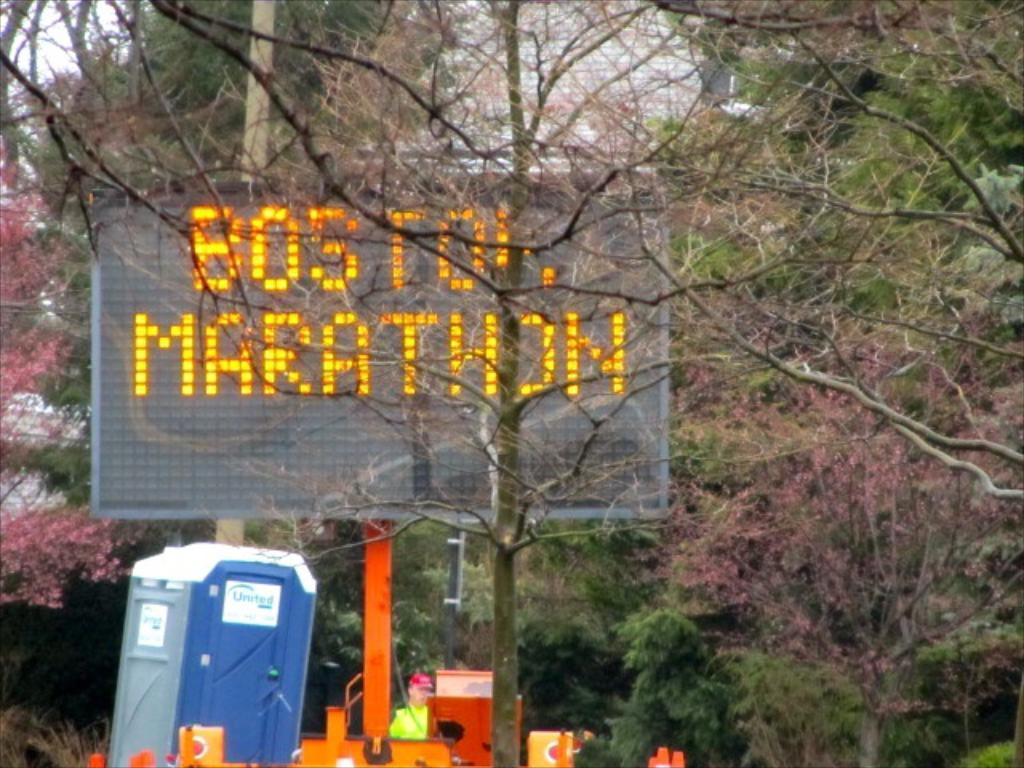Provide a one-sentence caption for the provided image. a large sign for the Boston marathon in orange. 